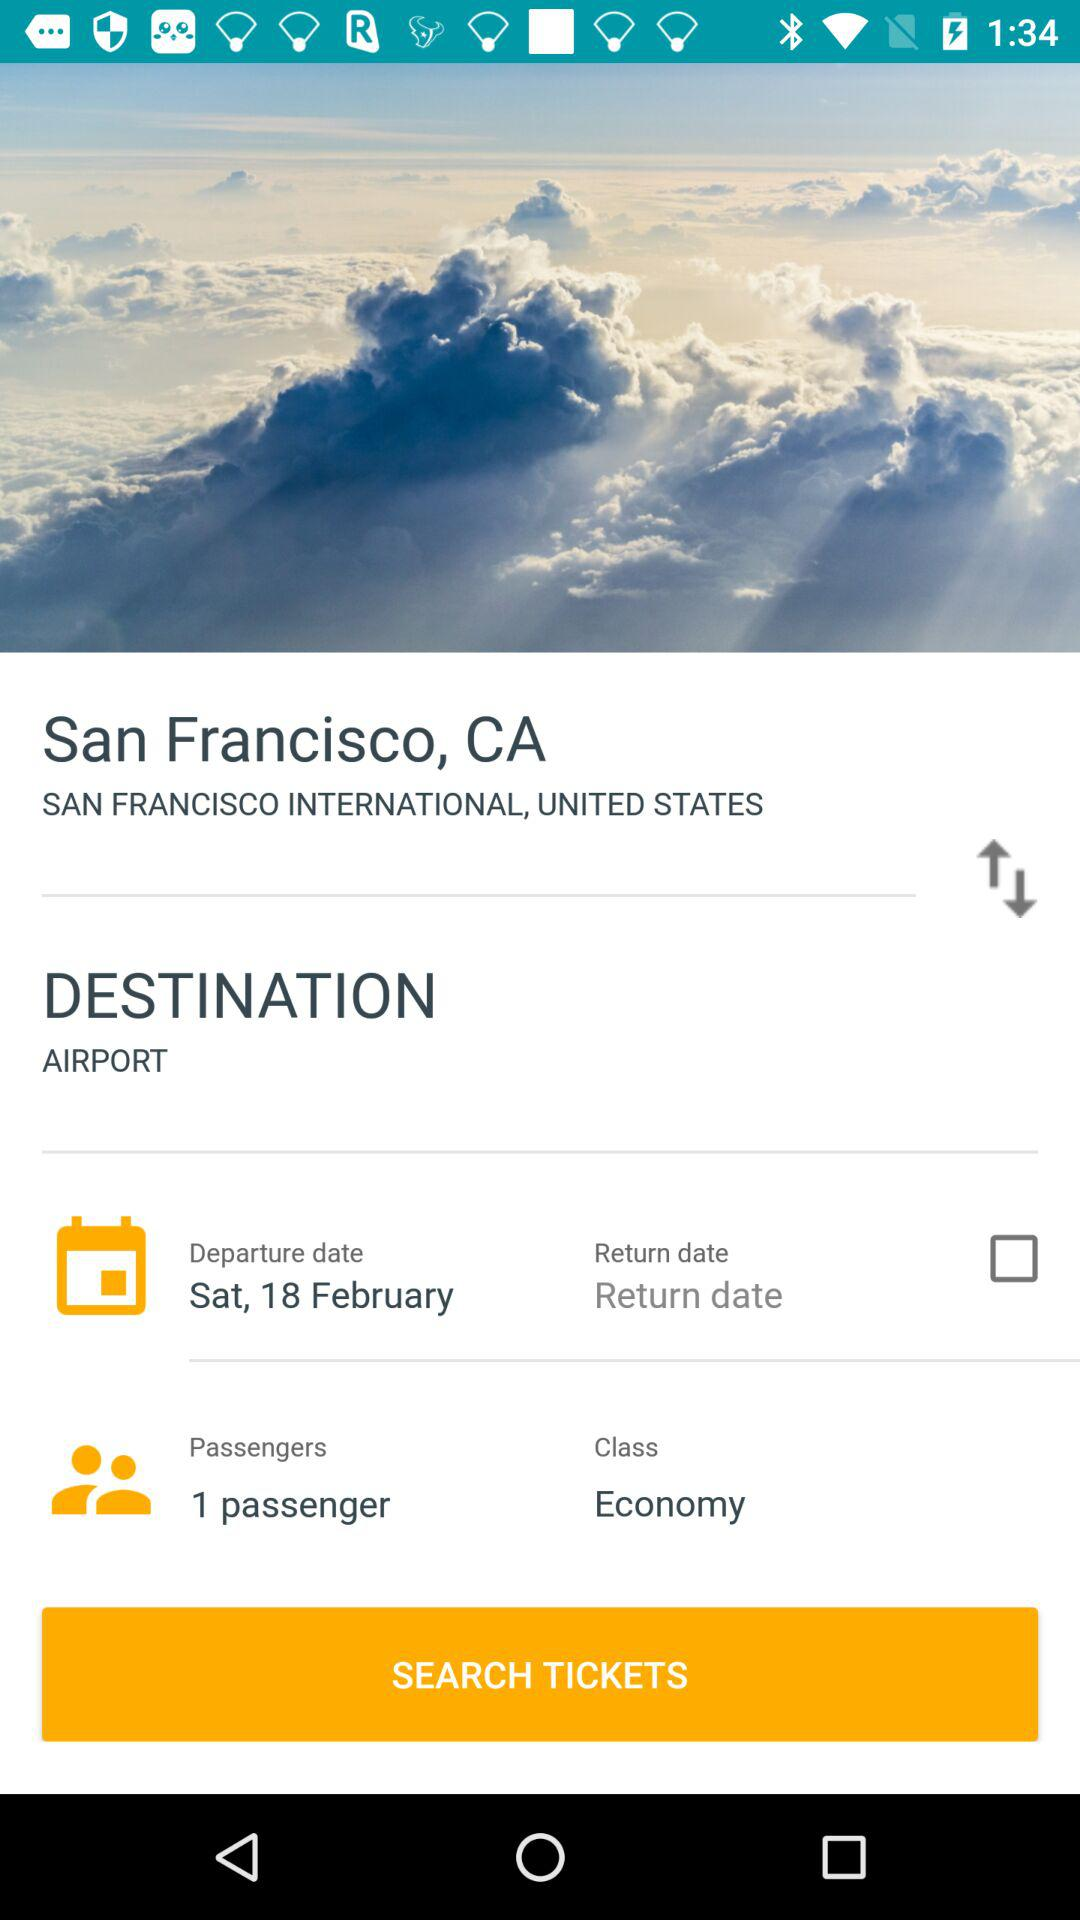What is the count of passengers? There is one passenger. 